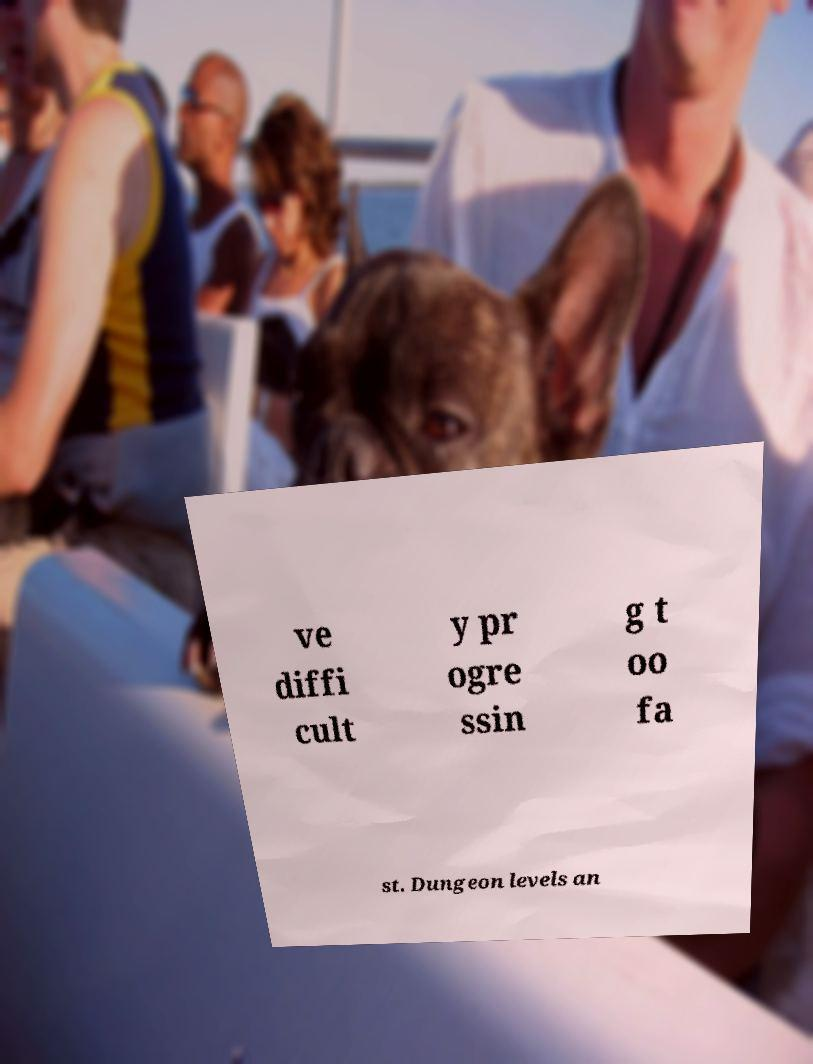For documentation purposes, I need the text within this image transcribed. Could you provide that? ve diffi cult y pr ogre ssin g t oo fa st. Dungeon levels an 